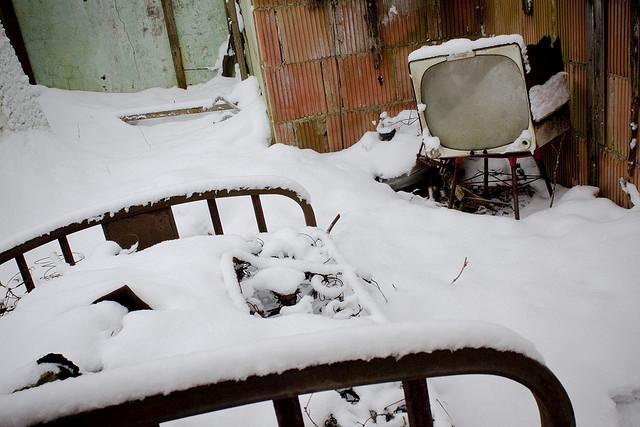Does the TV still work?
Write a very short answer. No. Is there snow?
Keep it brief. Yes. Would be bed be comfortable to sleep in?
Answer briefly. No. 